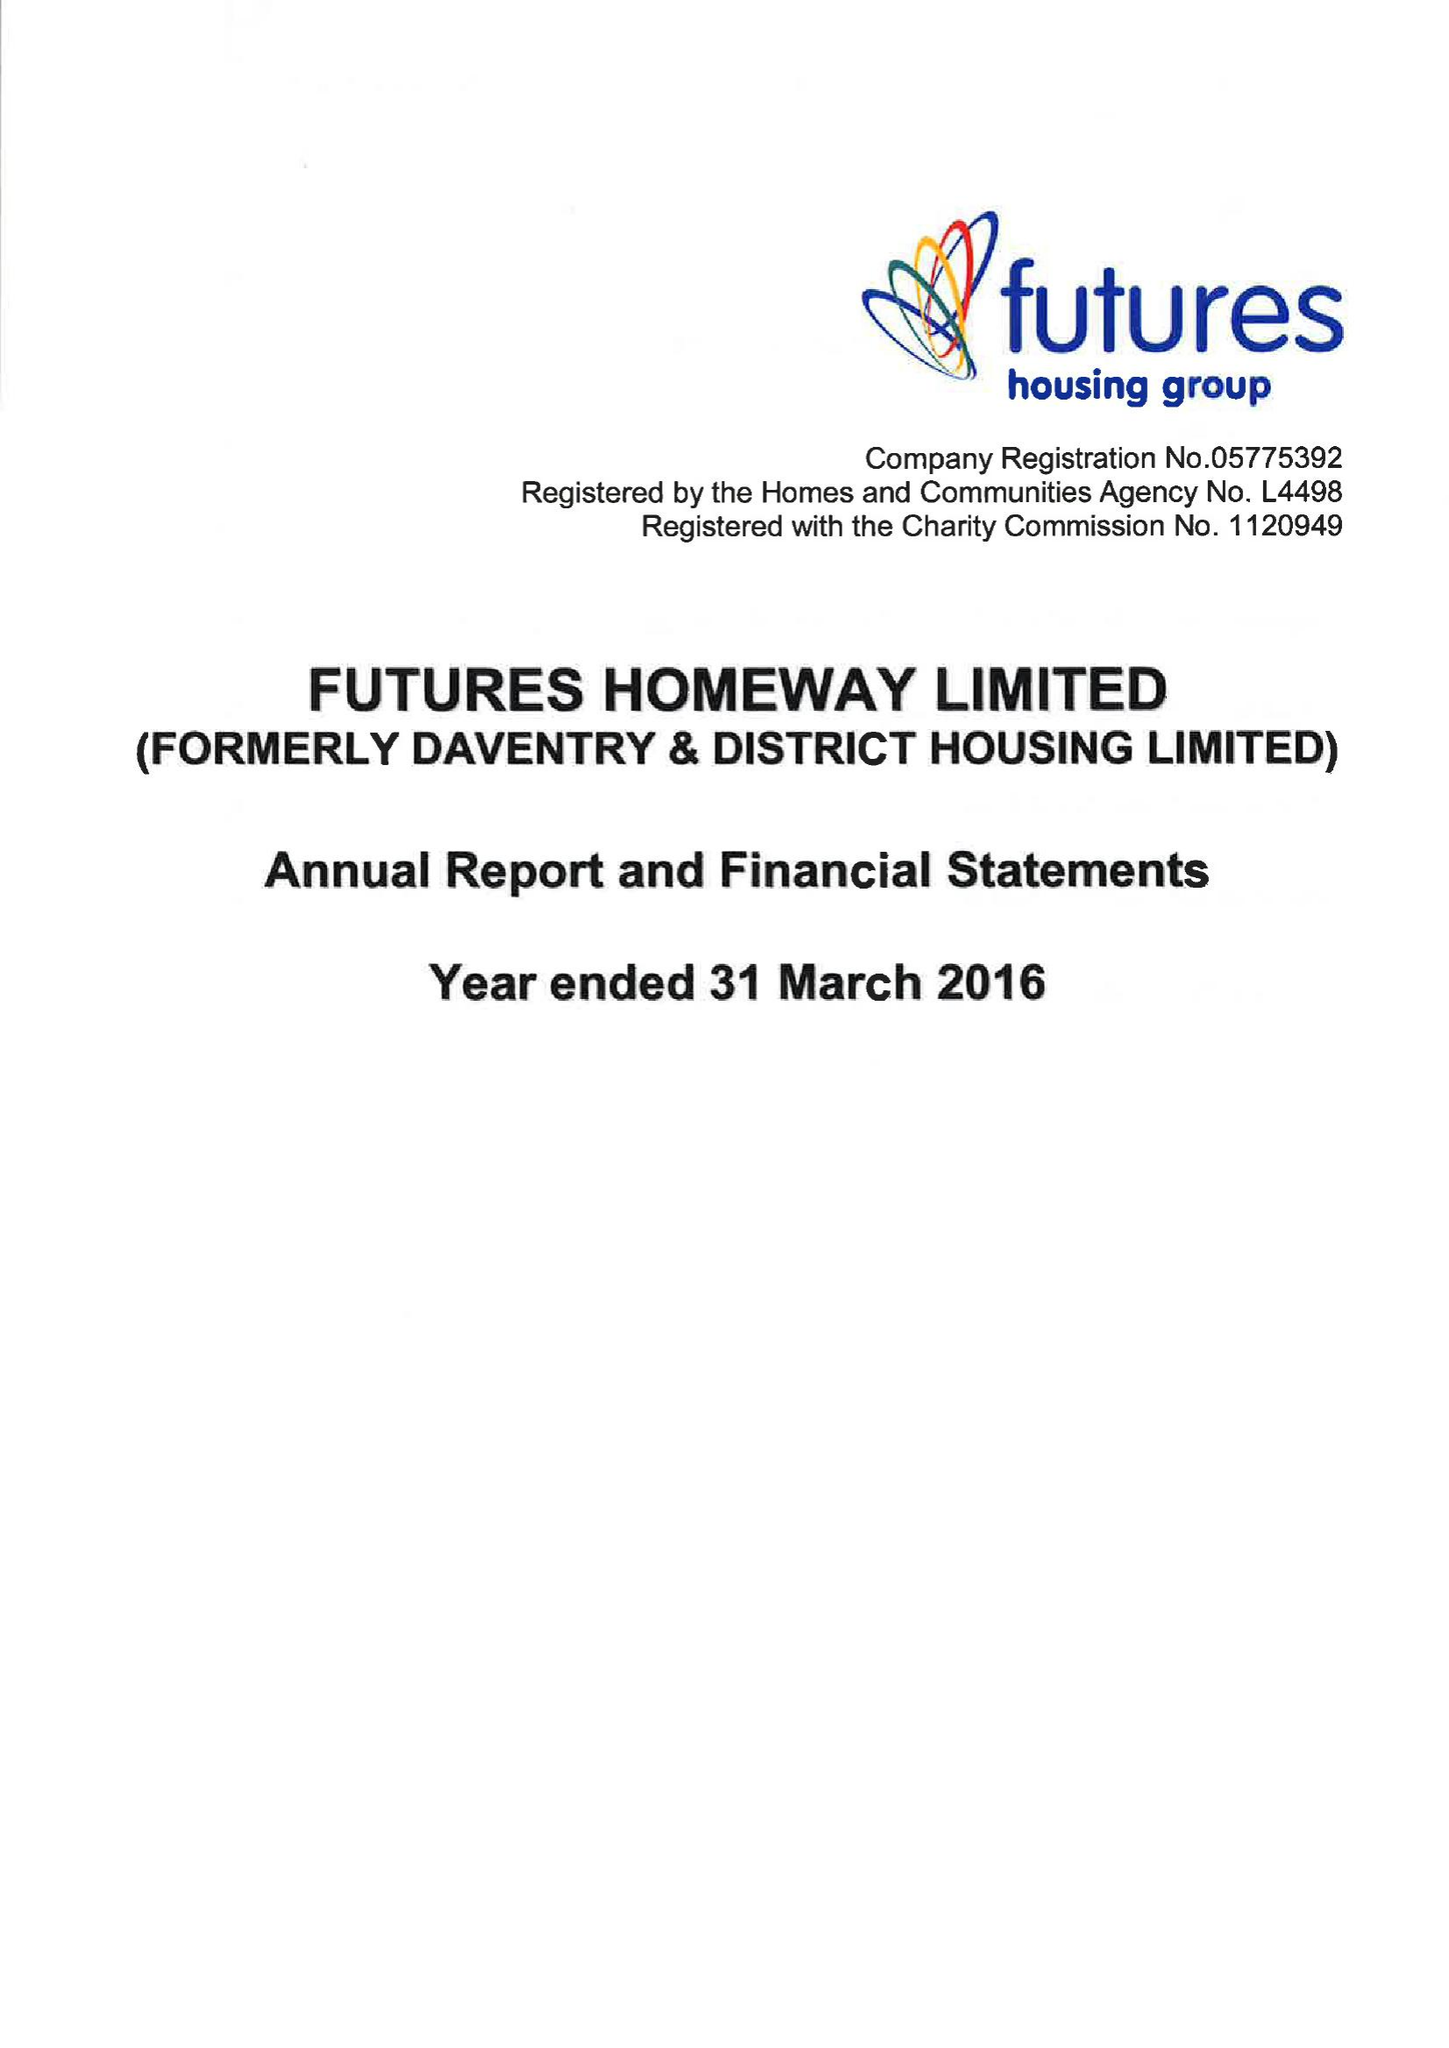What is the value for the address__street_line?
Answer the question using a single word or phrase. None 